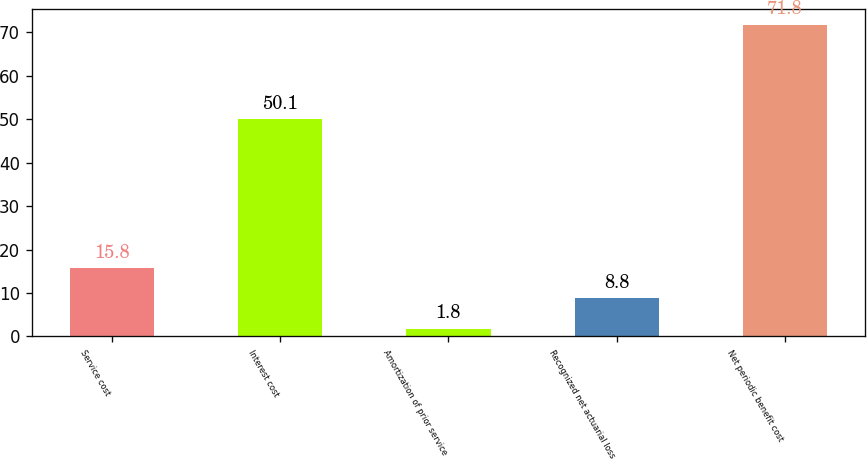<chart> <loc_0><loc_0><loc_500><loc_500><bar_chart><fcel>Service cost<fcel>Interest cost<fcel>Amortization of prior service<fcel>Recognized net actuarial loss<fcel>Net periodic benefit cost<nl><fcel>15.8<fcel>50.1<fcel>1.8<fcel>8.8<fcel>71.8<nl></chart> 